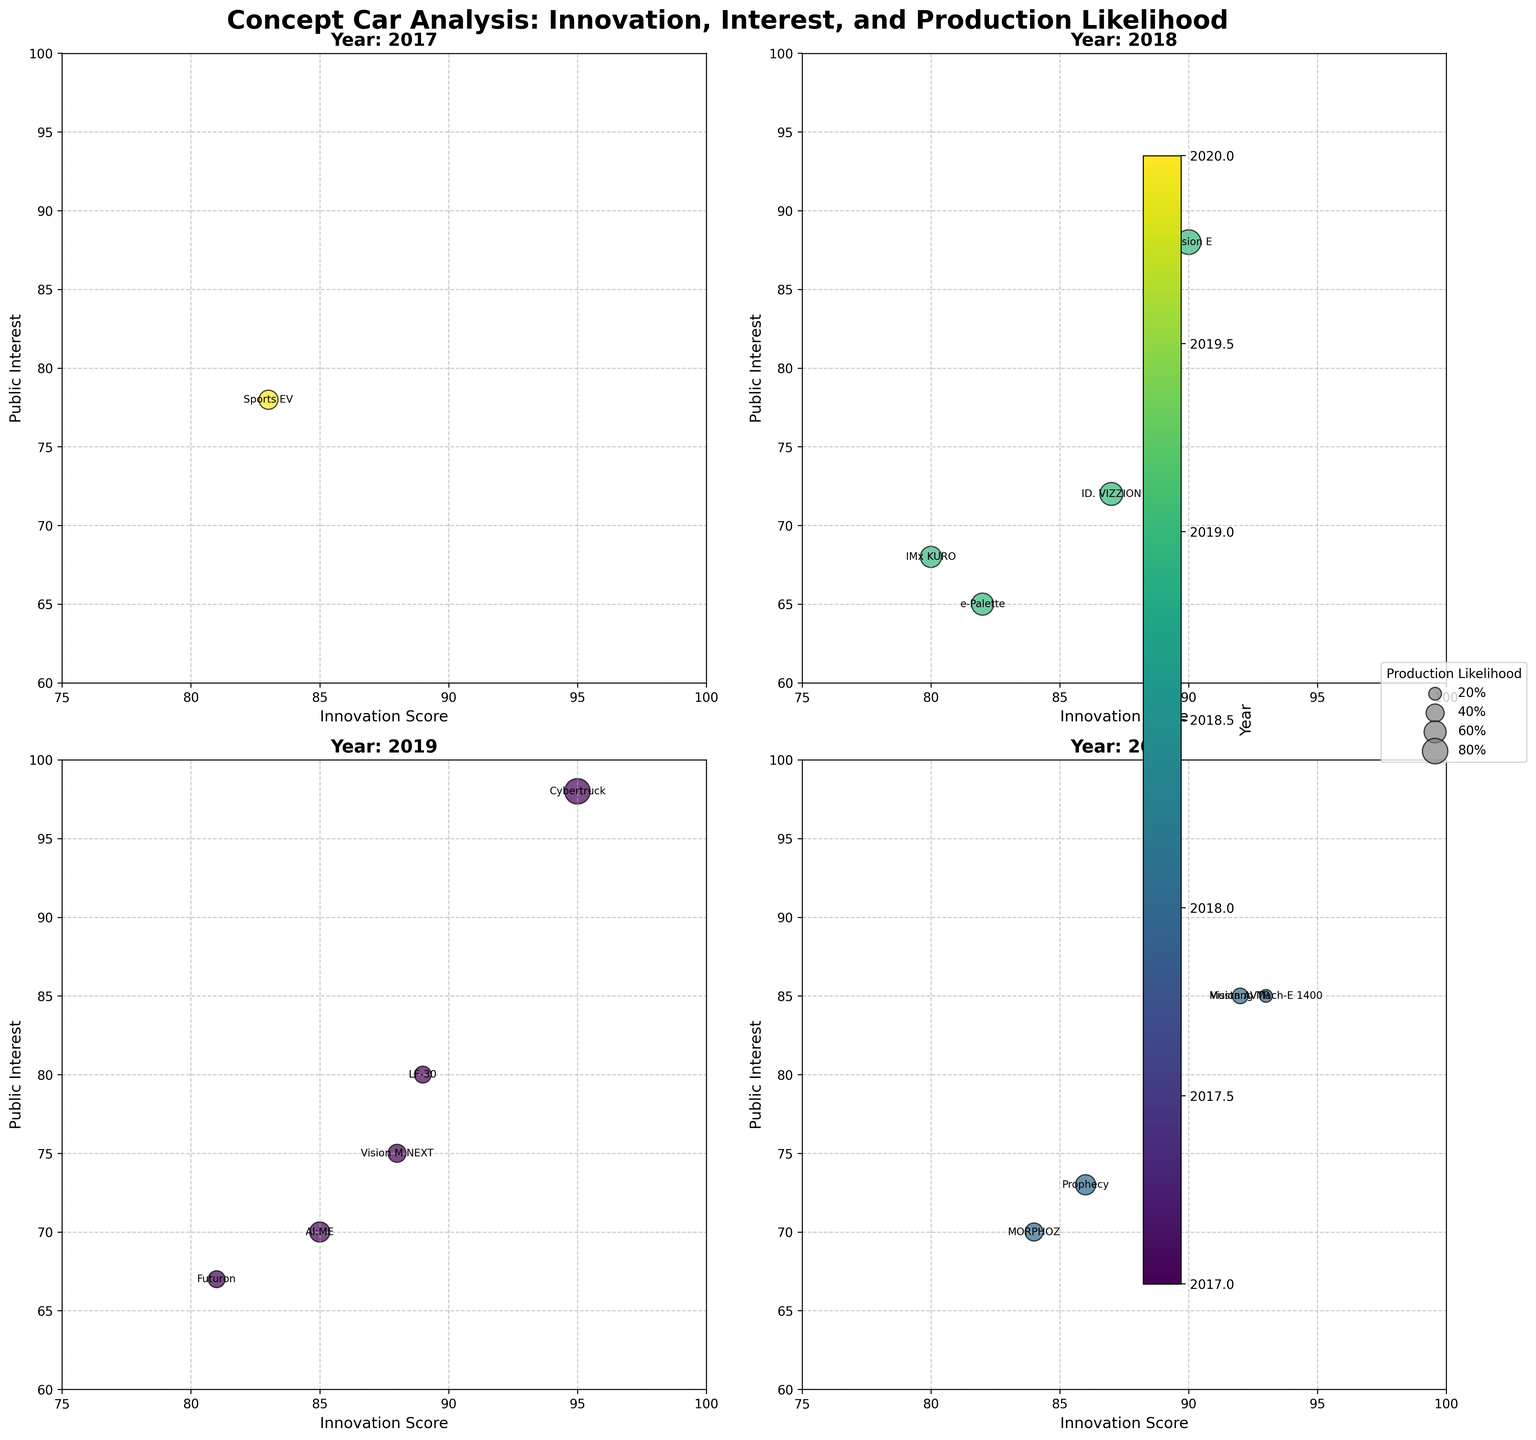When comparing the innovation scores, which model is the most innovative across all years? To determine the most innovative model, we compare the innovation scores of all car models across all years. The Tesla Cybertruck has an innovation score of 95, which is the highest among the listed models.
Answer: Tesla Cybertruck How does public interest vary with the innovation score in the year 2019? In 2019, the models are Tesla Cybertruck, BMW Vision M NEXT, Audi AI:ME, Lexus LF-30, and Kia Futuron. The public interest generally increases with the innovation score for these models: Cybertruck (95, 98), Vision M NEXT (88, 75), AI:ME (85, 70), LF-30 (89, 80), and Futuron (81, 67).
Answer: It increases Which model from 2020 has the highest production likelihood? For 2020, the models are Mercedes-Benz Vision AVTR, Ford Mustang Mach-E 1400, Hyundai Prophecy, and Renault MORPHOZ. Comparing their production likelihoods, Prophecy leads with a likelihood of 50%.
Answer: Hyundai Prophecy What car models were released in 2018 with a public interest above 70? The 2018 models are Porsche Mission E, Toyota e-Palette, Volkswagen ID. VIZZION, and Nissan IMx KURO. Among them, Mission E (88) and ID. VIZZION (72) have public interests above 70.
Answer: Porsche Mission E, Volkswagen ID. VIZZION Which year had the highest average innovation score among the concept cars presented? To find the year with the highest average innovation score, calculate the averages for each year:
2017: (83) / 1 = 83.
2018: (90 + 82 + 87 + 80) / 4 = 84.75.
2019: (95 + 88 + 85 + 89 + 81) / 5 = 87.6.
2020: (92 + 93 + 86 + 84) / 4 = 88.75.
Thus, 2020 has the highest average innovation score.
Answer: 2020 Compare the production likelihood for Tesla Cybertruck (2019) and Ford Mustang Mach-E 1400 (2020). Which is higher? Compare the production likelihoods for these models: Tesla Cybertruck (80) and Ford Mustang Mach-E 1400 (20). Clearly, Tesla Cybertruck has a significantly higher production likelihood.
Answer: Tesla Cybertruck How many models were released each year? Count the number of models for each year:
2017: 1 model,
2018: 4 models,
2019: 5 models,
2020: 4 models.
Answer: 2017: 1, 2018: 4, 2019: 5, 2020: 4 Which model has the lowest public interest and what is its score? Identify the model with the lowest public interest score by examining all years. The Toyota e-Palette from 2018 has the lowest score at 65.
Answer: Toyota e-Palette Which 2019 model has the smallest bubble size indicating its production likelihood? The 2019 models are Tesla Cybertruck, BMW Vision M NEXT, Audi AI:ME, Lexus LF-30, and Kia Futuron. Kia Futuron has the smallest bubble size, corresponding to a production likelihood of 35%.
Answer: Kia Futuron 